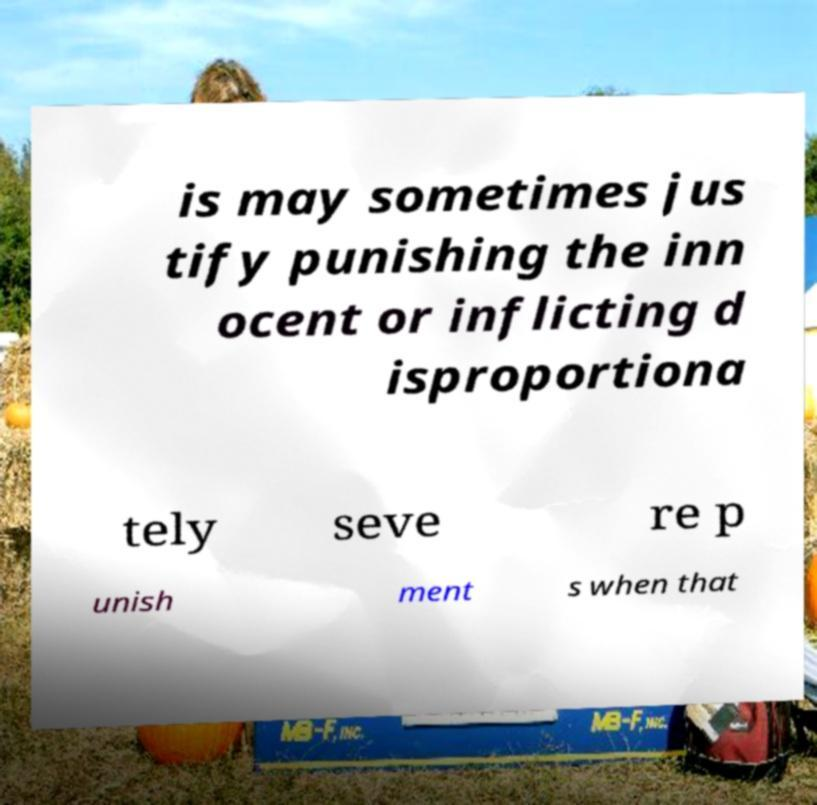Can you read and provide the text displayed in the image?This photo seems to have some interesting text. Can you extract and type it out for me? is may sometimes jus tify punishing the inn ocent or inflicting d isproportiona tely seve re p unish ment s when that 